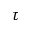Convert formula to latex. <formula><loc_0><loc_0><loc_500><loc_500>\tau</formula> 